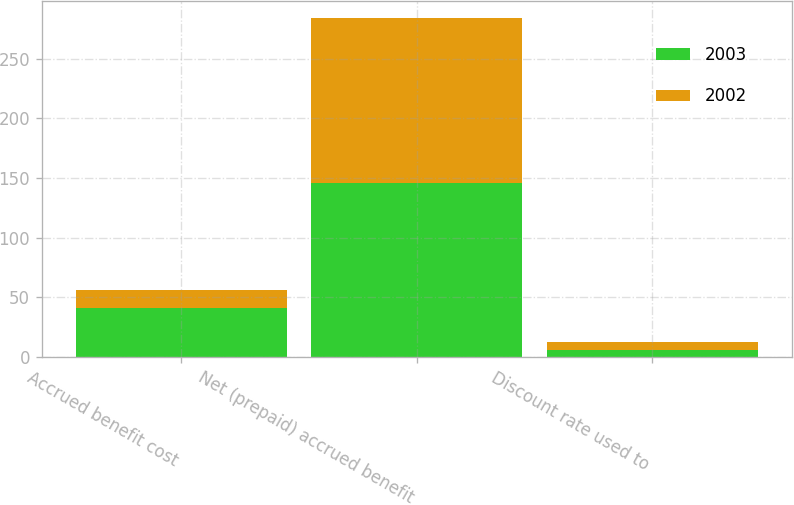Convert chart to OTSL. <chart><loc_0><loc_0><loc_500><loc_500><stacked_bar_chart><ecel><fcel>Accrued benefit cost<fcel>Net (prepaid) accrued benefit<fcel>Discount rate used to<nl><fcel>2003<fcel>41<fcel>146<fcel>6<nl><fcel>2002<fcel>15<fcel>138<fcel>6.75<nl></chart> 